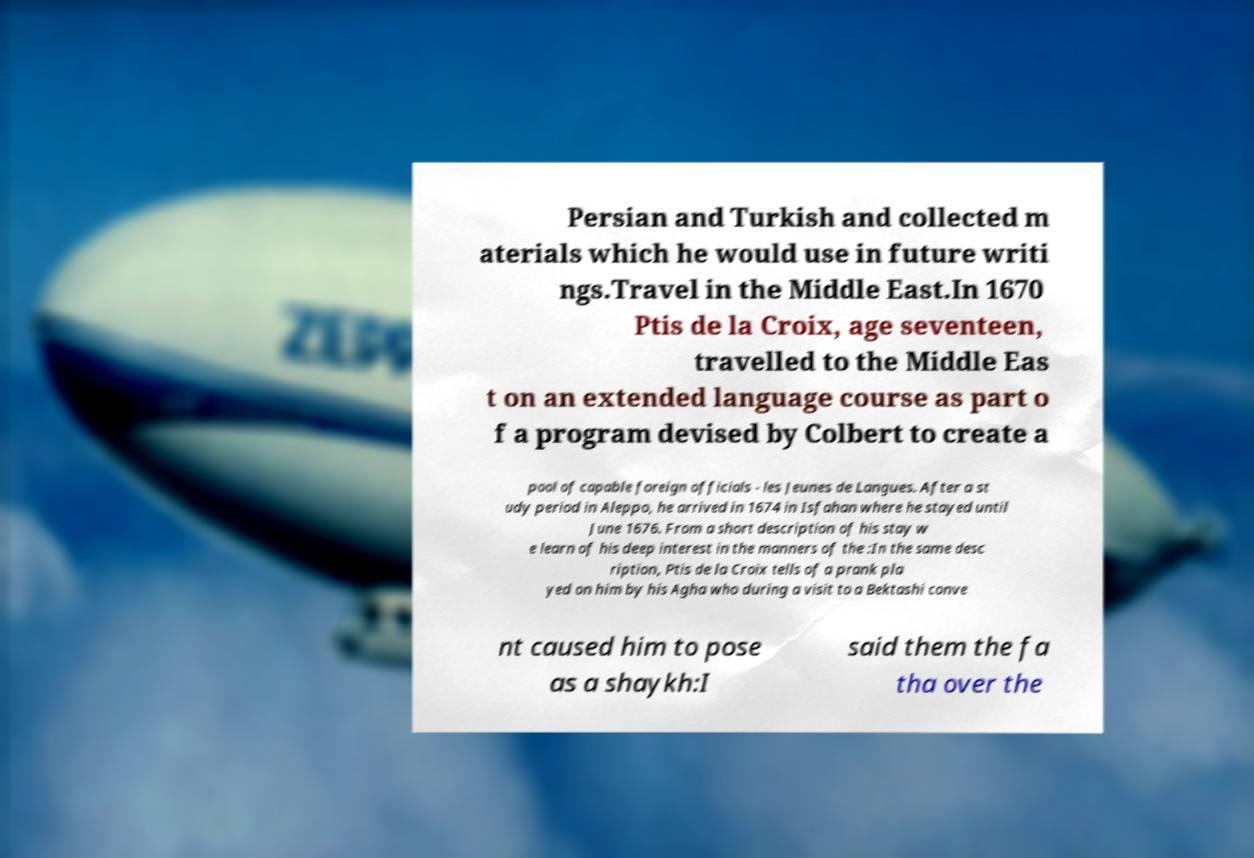Could you assist in decoding the text presented in this image and type it out clearly? Persian and Turkish and collected m aterials which he would use in future writi ngs.Travel in the Middle East.In 1670 Ptis de la Croix, age seventeen, travelled to the Middle Eas t on an extended language course as part o f a program devised by Colbert to create a pool of capable foreign officials - les Jeunes de Langues. After a st udy period in Aleppo, he arrived in 1674 in Isfahan where he stayed until June 1676. From a short description of his stay w e learn of his deep interest in the manners of the :In the same desc ription, Ptis de la Croix tells of a prank pla yed on him by his Agha who during a visit to a Bektashi conve nt caused him to pose as a shaykh:I said them the fa tha over the 